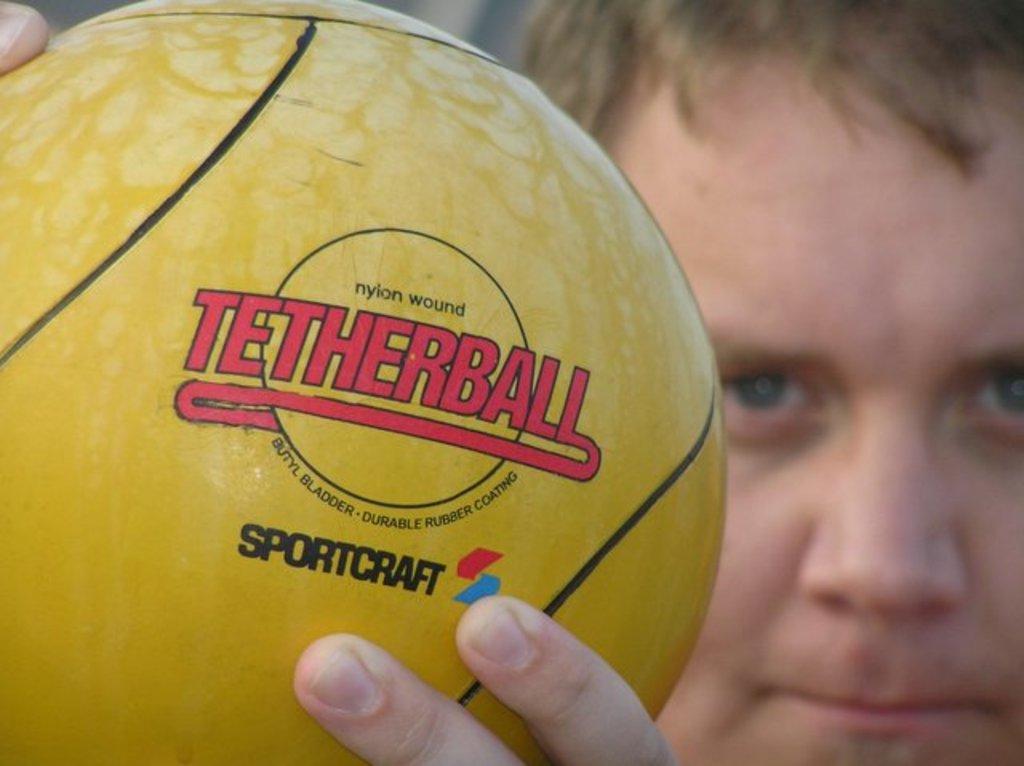What kind of ball is this?
Offer a terse response. Tetherball. What is the ball made of?
Offer a terse response. Nylon. 